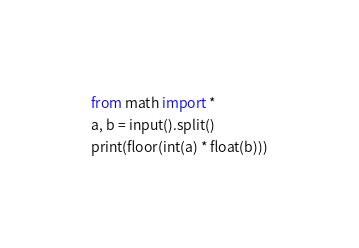Convert code to text. <code><loc_0><loc_0><loc_500><loc_500><_Python_>from math import *
a, b = input().split()
print(floor(int(a) * float(b)))</code> 